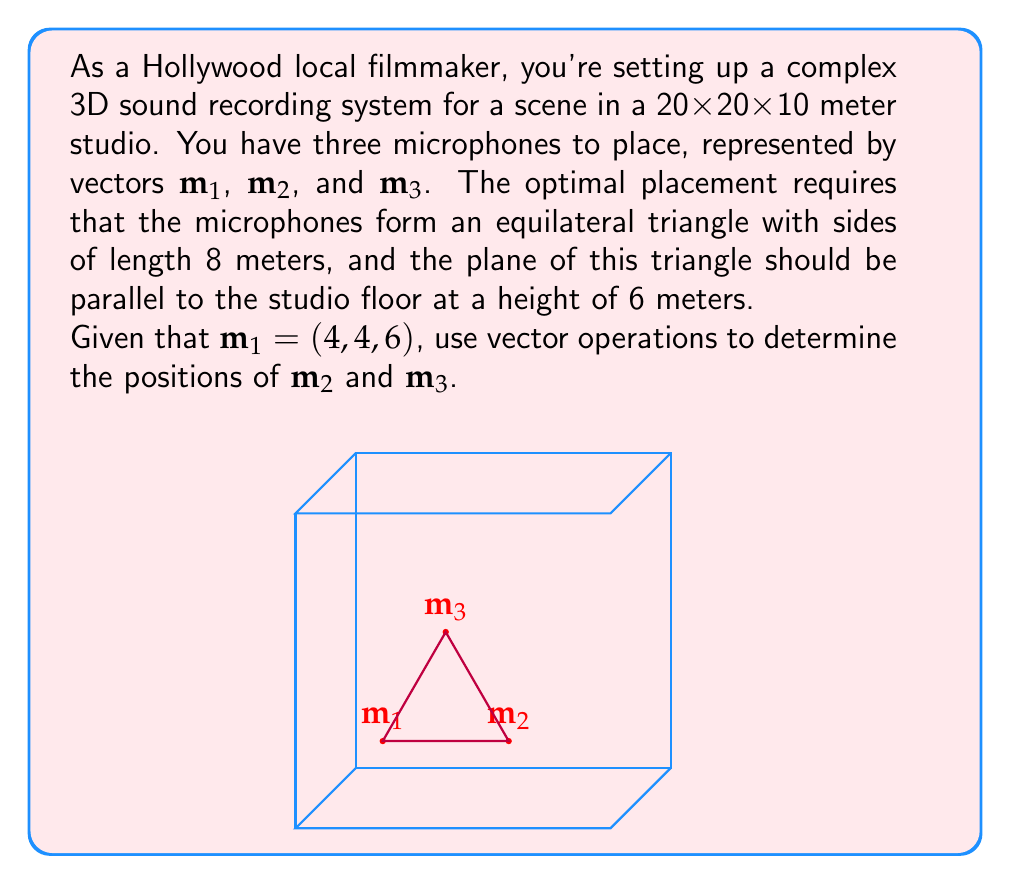Give your solution to this math problem. Let's approach this step-by-step:

1) First, we know that $\mathbf{m}_1 = (4, 4, 6)$. The triangle is parallel to the floor, so all z-coordinates will be 6.

2) To find $\mathbf{m}_2$, we need to move 8 units along the x-axis from $\mathbf{m}_1$:
   $\mathbf{m}_2 = (4+8, 4, 6) = (12, 4, 6)$

3) For $\mathbf{m}_3$, we need to form an equilateral triangle. The vector from $\mathbf{m}_1$ to $\mathbf{m}_3$ should be:
   $\mathbf{v} = (4, 4\sqrt{3}, 0)$

   This is because:
   - The x-component is half of the base (4)
   - The y-component is the height of an equilateral triangle: $4\sqrt{3}$
   - The z-component is 0 as we're moving parallel to the floor

4) To get $\mathbf{m}_3$, we add this vector to $\mathbf{m}_1$:
   $\mathbf{m}_3 = (4, 4, 6) + (4, 4\sqrt{3}, 0) = (8, 4+4\sqrt{3}, 6)$

5) We can verify that the distance between any two points is 8:
   $|\mathbf{m}_2 - \mathbf{m}_1| = |(8, 0, 0)| = 8$
   $|\mathbf{m}_3 - \mathbf{m}_1| = |(4, 4\sqrt{3}, 0)| = \sqrt{16 + 48} = 8$
   $|\mathbf{m}_3 - \mathbf{m}_2| = |(-4, 4\sqrt{3}, 0)| = \sqrt{16 + 48} = 8$
Answer: $\mathbf{m}_2 = (12, 4, 6)$, $\mathbf{m}_3 = (8, 4+4\sqrt{3}, 6)$ 